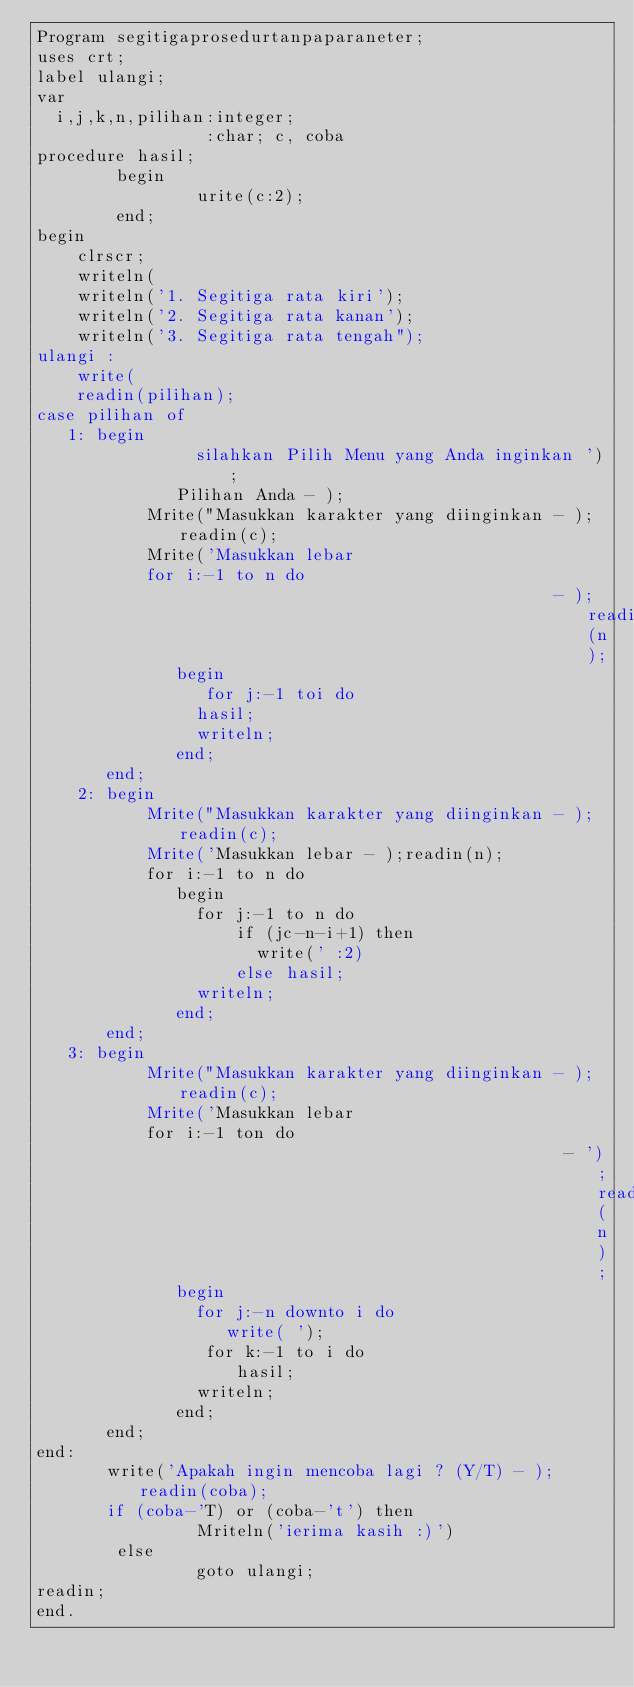<code> <loc_0><loc_0><loc_500><loc_500><_Pascal_>Program segitigaprosedurtanpaparaneter;
uses crt;
label ulangi;
var
  i,j,k,n,pilihan:integer;
                 :char; c, coba
procedure hasil;
        begin
                urite(c:2);
        end;
begin
    clrscr;
    writeln(
    writeln('1. Segitiga rata kiri');
    writeln('2. Segitiga rata kanan');
    writeln('3. Segitiga rata tengah");
ulangi :
    write(
    readin(pilihan);
case pilihan of
   1: begin
                silahkan Pilih Menu yang Anda inginkan ');
              Pilihan Anda - );
           Mrite("Masukkan karakter yang diinginkan - );readin(c);
           Mrite('Masukkan lebar
           for i:-1 to n do
                                                    - );readin(n);
              begin
                 for j:-1 toi do
                hasil;
                writeln;
              end;
       end;
    2: begin
           Mrite("Masukkan karakter yang diinginkan - );readin(c);
           Mrite('Masukkan lebar - );readin(n);
           for i:-1 to n do
              begin
                for j:-1 to n do
                    if (jc-n-i+1) then
                      write(' :2)
                    else hasil;
                writeln;
              end;
       end;
   3: begin
           Mrite("Masukkan karakter yang diinginkan - );readin(c);
           Mrite('Masukkan lebar
           for i:-1 ton do
                                                     - ');readin(n);
              begin
                for j:-n downto i do
                   write( ');
                 for k:-1 to i do
                    hasil;
                writeln;
              end;
       end;
end:
       write('Apakah ingin mencoba lagi ? (Y/T) - ); readin(coba);
       if (coba-'T) or (coba-'t') then
                Mriteln('ierima kasih :)')
        else
                goto ulangi;
readin;
end.</code> 